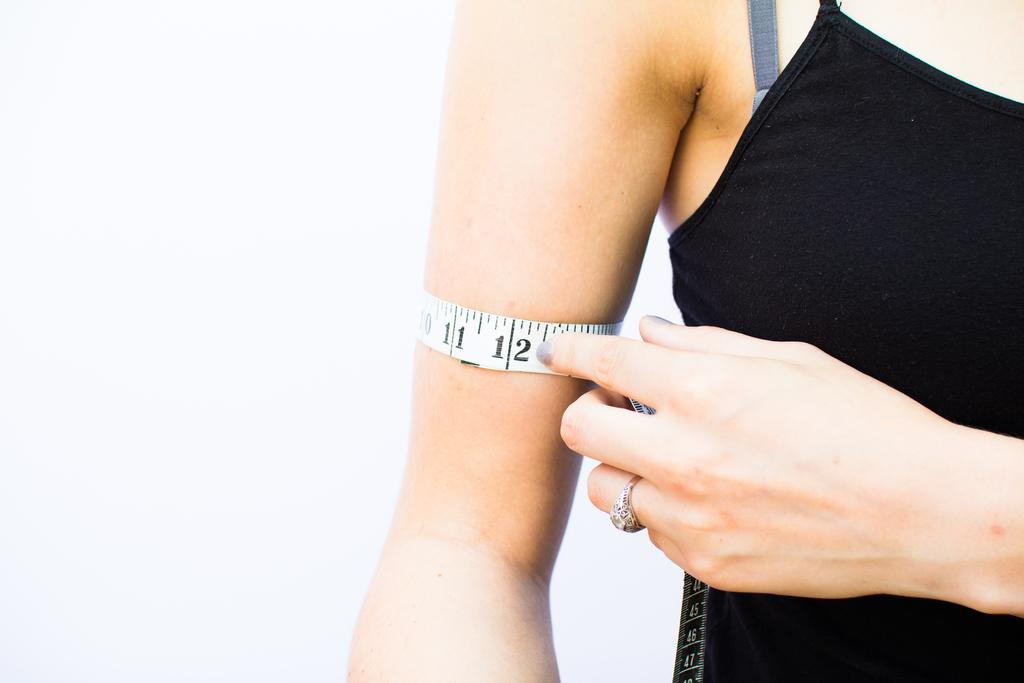Who is present in the image? There is a woman in the image. What is the woman wearing? The woman is wearing clothes. Are there any accessories visible on the woman? Yes, the woman is wearing a finger ring. What tool can be seen in the image? There is a measuring tape in the image. What type of party is being held in the image? There is no indication of a party in the image; it only features a woman, her clothing, a finger ring, and a measuring tape. How many trays are visible in the image? There are no trays present in the image. 